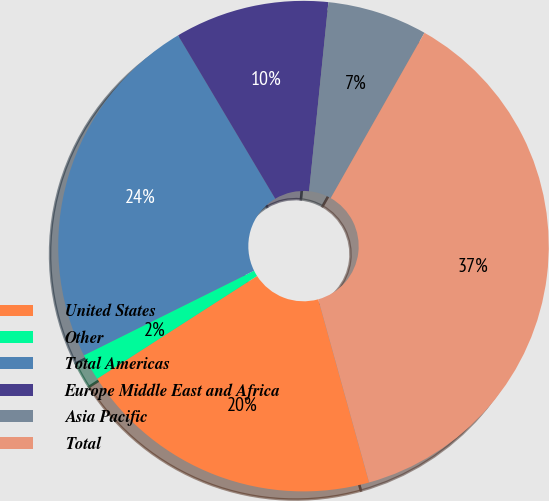Convert chart to OTSL. <chart><loc_0><loc_0><loc_500><loc_500><pie_chart><fcel>United States<fcel>Other<fcel>Total Americas<fcel>Europe Middle East and Africa<fcel>Asia Pacific<fcel>Total<nl><fcel>20.22%<fcel>1.75%<fcel>23.8%<fcel>10.16%<fcel>6.59%<fcel>37.48%<nl></chart> 